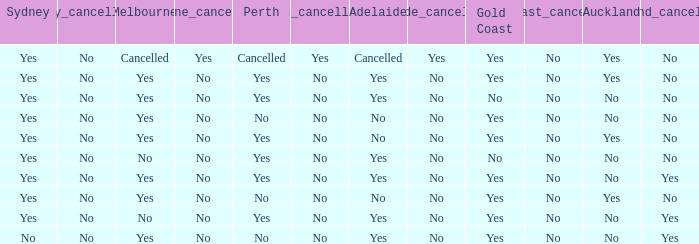What is the sydney that has adelaide, gold coast, melbourne, and auckland are all yes? Yes. Would you be able to parse every entry in this table? {'header': ['Sydney', 'Sydney_cancellation', 'Melbourne', 'Melbourne_cancellation', 'Perth', 'Perth_cancellation', 'Adelaide', 'Adelaide_cancellation', 'Gold Coast', 'Gold_Coast_cancellation', 'Auckland', 'Auckland_cancellation'], 'rows': [['Yes', 'No', 'Cancelled', 'Yes', 'Cancelled', 'Yes', 'Cancelled', 'Yes', 'Yes', 'No', 'Yes', 'No'], ['Yes', 'No', 'Yes', 'No', 'Yes', 'No', 'Yes', 'No', 'Yes', 'No', 'Yes', 'No'], ['Yes', 'No', 'Yes', 'No', 'Yes', 'No', 'Yes', 'No', 'No', 'No', 'No', 'No'], ['Yes', 'No', 'Yes', 'No', 'No', 'No', 'No', 'No', 'Yes', 'No', 'No', 'No'], ['Yes', 'No', 'Yes', 'No', 'Yes', 'No', 'No', 'No', 'Yes', 'No', 'Yes', 'No'], ['Yes', 'No', 'No', 'No', 'Yes', 'No', 'Yes', 'No', 'No', 'No', 'No', 'No'], ['Yes', 'No', 'Yes', 'No', 'Yes', 'No', 'Yes', 'No', 'Yes', 'No', 'No', 'Yes'], ['Yes', 'No', 'Yes', 'No', 'No', 'No', 'No', 'No', 'Yes', 'No', 'Yes', 'No'], ['Yes', 'No', 'No', 'No', 'Yes', 'No', 'Yes', 'No', 'Yes', 'No', 'No', 'Yes'], ['No', 'No', 'Yes', 'No', 'No', 'No', 'Yes', 'No', 'Yes', 'No', 'No', 'Yes']]} 